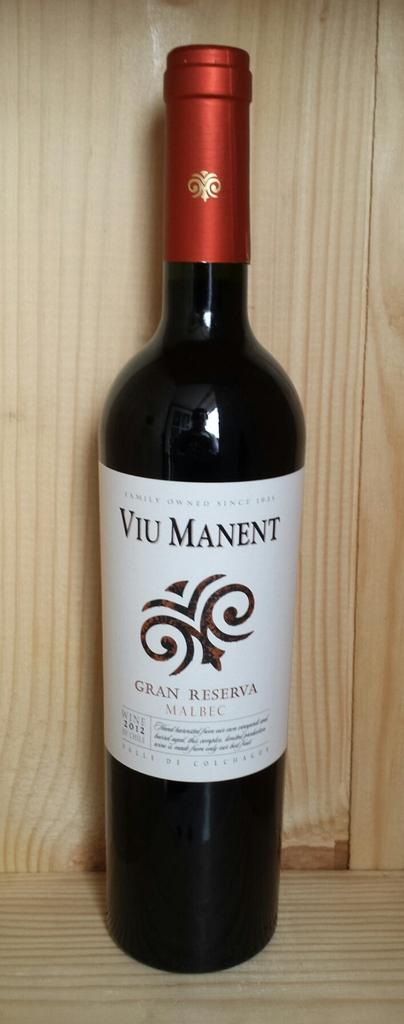Provide a one-sentence caption for the provided image. an alcohol bottle with VIU MANENT on the label. 